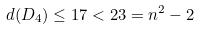<formula> <loc_0><loc_0><loc_500><loc_500>d ( D _ { 4 } ) \leq 1 7 < 2 3 = n ^ { 2 } - 2</formula> 